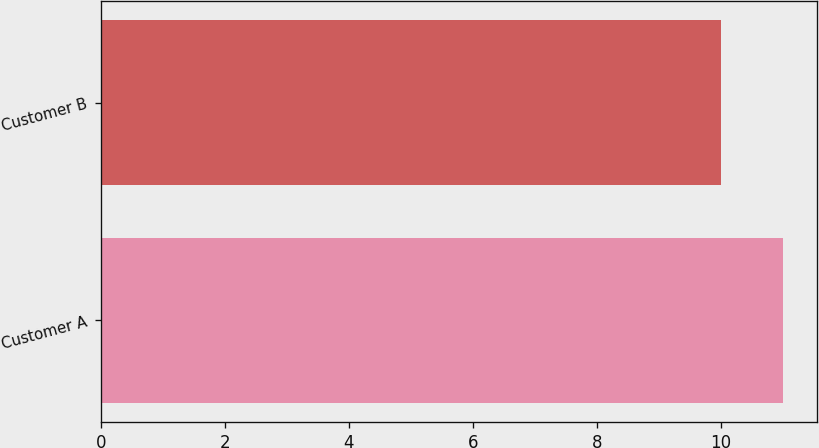<chart> <loc_0><loc_0><loc_500><loc_500><bar_chart><fcel>Customer A<fcel>Customer B<nl><fcel>11<fcel>10<nl></chart> 